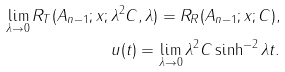<formula> <loc_0><loc_0><loc_500><loc_500>\lim _ { \lambda \to 0 } R _ { T } ( A _ { n - 1 } ; x ; \lambda ^ { 2 } C , \lambda ) = R _ { R } ( A _ { n - 1 } ; x ; C ) , \\ u ( t ) = \lim _ { \lambda \to 0 } \lambda ^ { 2 } C \sinh ^ { - 2 } \lambda t .</formula> 